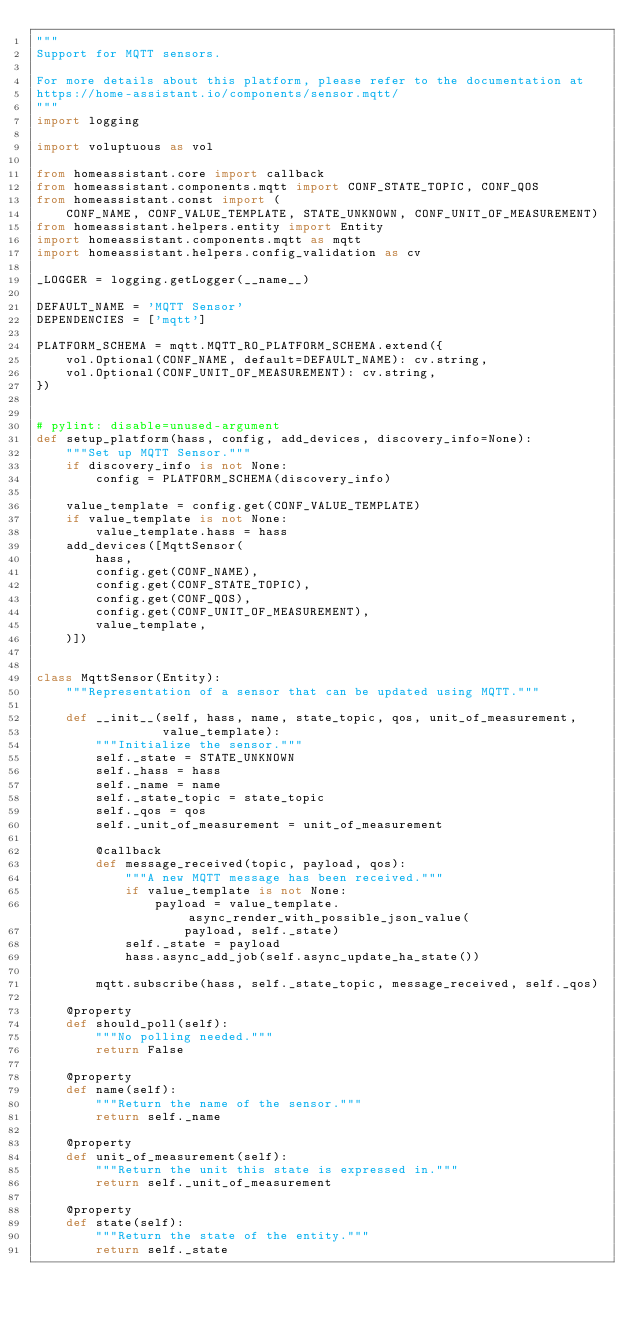Convert code to text. <code><loc_0><loc_0><loc_500><loc_500><_Python_>"""
Support for MQTT sensors.

For more details about this platform, please refer to the documentation at
https://home-assistant.io/components/sensor.mqtt/
"""
import logging

import voluptuous as vol

from homeassistant.core import callback
from homeassistant.components.mqtt import CONF_STATE_TOPIC, CONF_QOS
from homeassistant.const import (
    CONF_NAME, CONF_VALUE_TEMPLATE, STATE_UNKNOWN, CONF_UNIT_OF_MEASUREMENT)
from homeassistant.helpers.entity import Entity
import homeassistant.components.mqtt as mqtt
import homeassistant.helpers.config_validation as cv

_LOGGER = logging.getLogger(__name__)

DEFAULT_NAME = 'MQTT Sensor'
DEPENDENCIES = ['mqtt']

PLATFORM_SCHEMA = mqtt.MQTT_RO_PLATFORM_SCHEMA.extend({
    vol.Optional(CONF_NAME, default=DEFAULT_NAME): cv.string,
    vol.Optional(CONF_UNIT_OF_MEASUREMENT): cv.string,
})


# pylint: disable=unused-argument
def setup_platform(hass, config, add_devices, discovery_info=None):
    """Set up MQTT Sensor."""
    if discovery_info is not None:
        config = PLATFORM_SCHEMA(discovery_info)

    value_template = config.get(CONF_VALUE_TEMPLATE)
    if value_template is not None:
        value_template.hass = hass
    add_devices([MqttSensor(
        hass,
        config.get(CONF_NAME),
        config.get(CONF_STATE_TOPIC),
        config.get(CONF_QOS),
        config.get(CONF_UNIT_OF_MEASUREMENT),
        value_template,
    )])


class MqttSensor(Entity):
    """Representation of a sensor that can be updated using MQTT."""

    def __init__(self, hass, name, state_topic, qos, unit_of_measurement,
                 value_template):
        """Initialize the sensor."""
        self._state = STATE_UNKNOWN
        self._hass = hass
        self._name = name
        self._state_topic = state_topic
        self._qos = qos
        self._unit_of_measurement = unit_of_measurement

        @callback
        def message_received(topic, payload, qos):
            """A new MQTT message has been received."""
            if value_template is not None:
                payload = value_template.async_render_with_possible_json_value(
                    payload, self._state)
            self._state = payload
            hass.async_add_job(self.async_update_ha_state())

        mqtt.subscribe(hass, self._state_topic, message_received, self._qos)

    @property
    def should_poll(self):
        """No polling needed."""
        return False

    @property
    def name(self):
        """Return the name of the sensor."""
        return self._name

    @property
    def unit_of_measurement(self):
        """Return the unit this state is expressed in."""
        return self._unit_of_measurement

    @property
    def state(self):
        """Return the state of the entity."""
        return self._state
</code> 